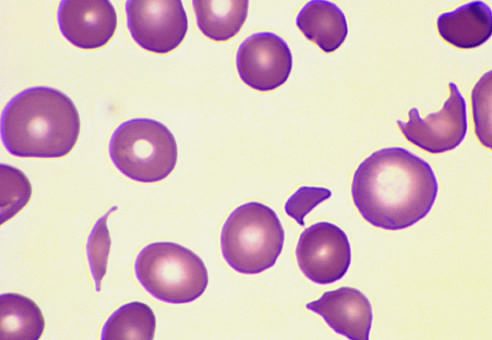do those with tumors that had mycn amplification contain several fragmented red cells?
Answer the question using a single word or phrase. No 